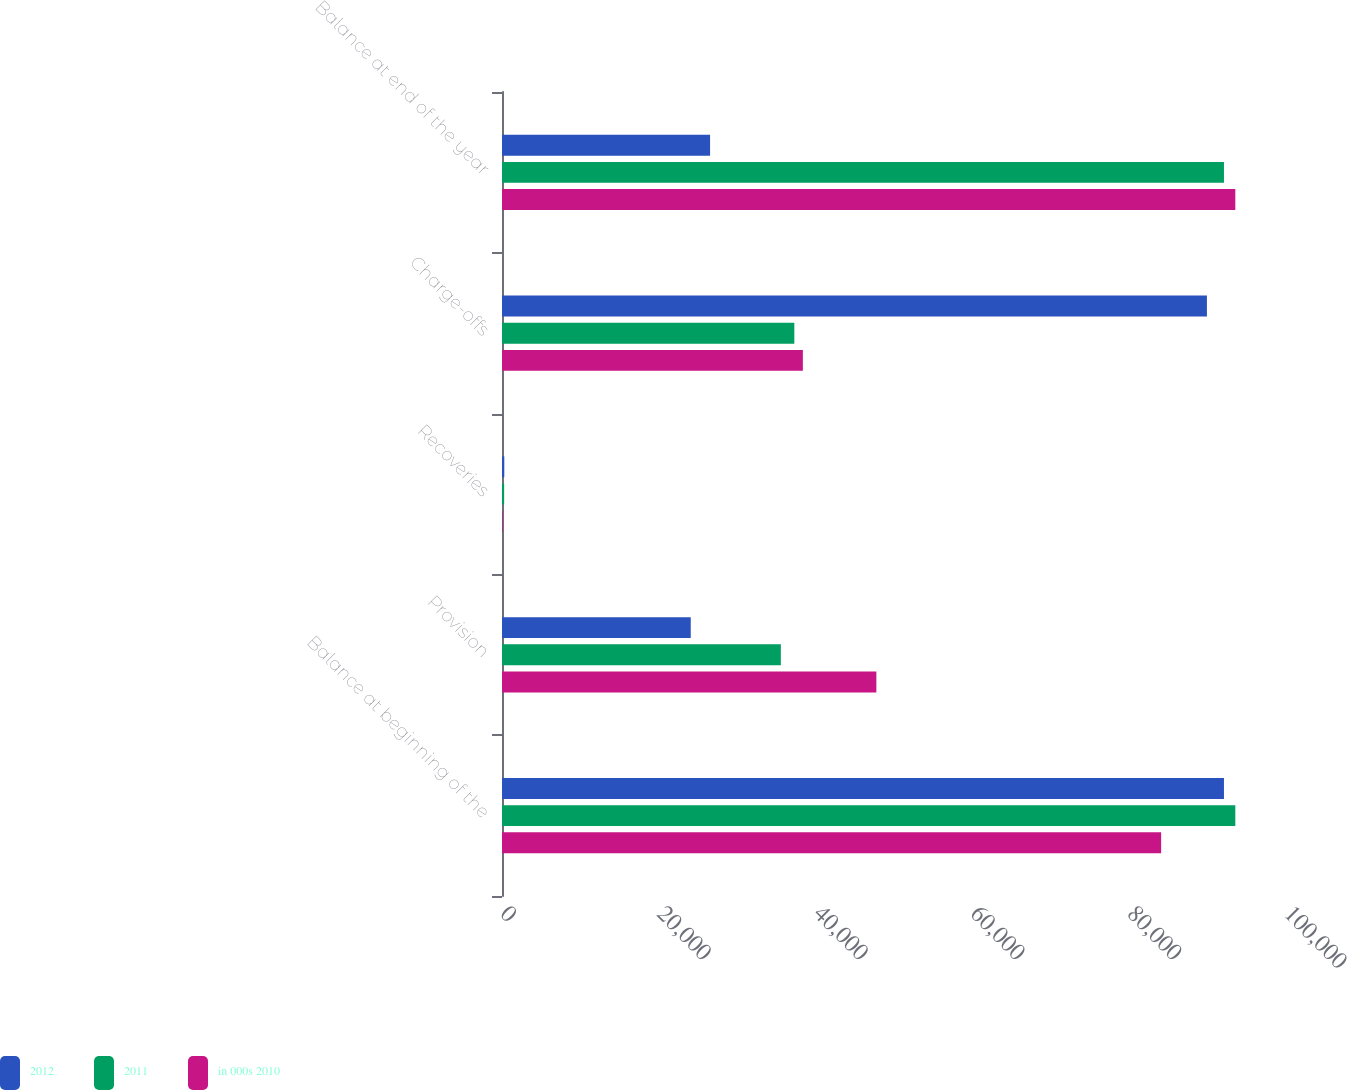Convert chart. <chart><loc_0><loc_0><loc_500><loc_500><stacked_bar_chart><ecel><fcel>Balance at beginning of the<fcel>Provision<fcel>Recoveries<fcel>Charge-offs<fcel>Balance at end of the year<nl><fcel>2012<fcel>92087<fcel>24075<fcel>292<fcel>89914<fcel>26540<nl><fcel>2011<fcel>93535<fcel>35567<fcel>272<fcel>37287<fcel>92087<nl><fcel>in 000s 2010<fcel>84073<fcel>47750<fcel>88<fcel>38376<fcel>93535<nl></chart> 